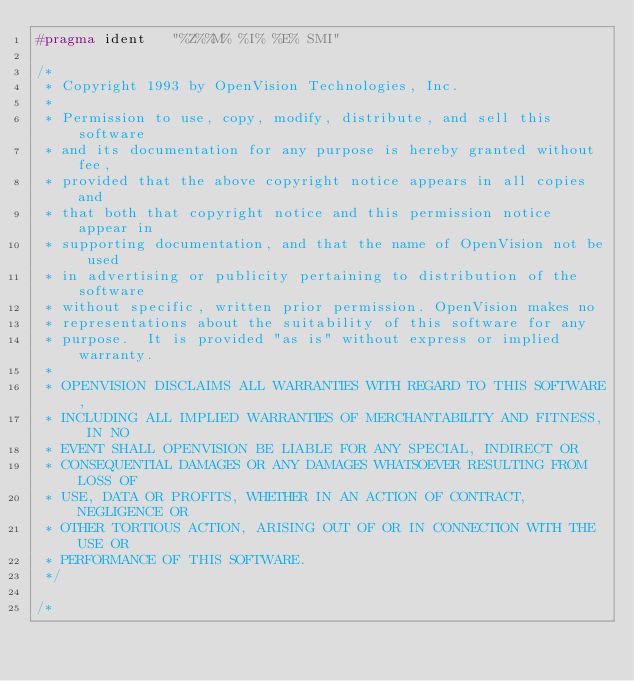<code> <loc_0><loc_0><loc_500><loc_500><_C_>#pragma ident	"%Z%%M%	%I%	%E% SMI"

/*
 * Copyright 1993 by OpenVision Technologies, Inc.
 * 
 * Permission to use, copy, modify, distribute, and sell this software
 * and its documentation for any purpose is hereby granted without fee,
 * provided that the above copyright notice appears in all copies and
 * that both that copyright notice and this permission notice appear in
 * supporting documentation, and that the name of OpenVision not be used
 * in advertising or publicity pertaining to distribution of the software
 * without specific, written prior permission. OpenVision makes no
 * representations about the suitability of this software for any
 * purpose.  It is provided "as is" without express or implied warranty.
 * 
 * OPENVISION DISCLAIMS ALL WARRANTIES WITH REGARD TO THIS SOFTWARE,
 * INCLUDING ALL IMPLIED WARRANTIES OF MERCHANTABILITY AND FITNESS, IN NO
 * EVENT SHALL OPENVISION BE LIABLE FOR ANY SPECIAL, INDIRECT OR
 * CONSEQUENTIAL DAMAGES OR ANY DAMAGES WHATSOEVER RESULTING FROM LOSS OF
 * USE, DATA OR PROFITS, WHETHER IN AN ACTION OF CONTRACT, NEGLIGENCE OR
 * OTHER TORTIOUS ACTION, ARISING OUT OF OR IN CONNECTION WITH THE USE OR
 * PERFORMANCE OF THIS SOFTWARE.
 */

/*</code> 